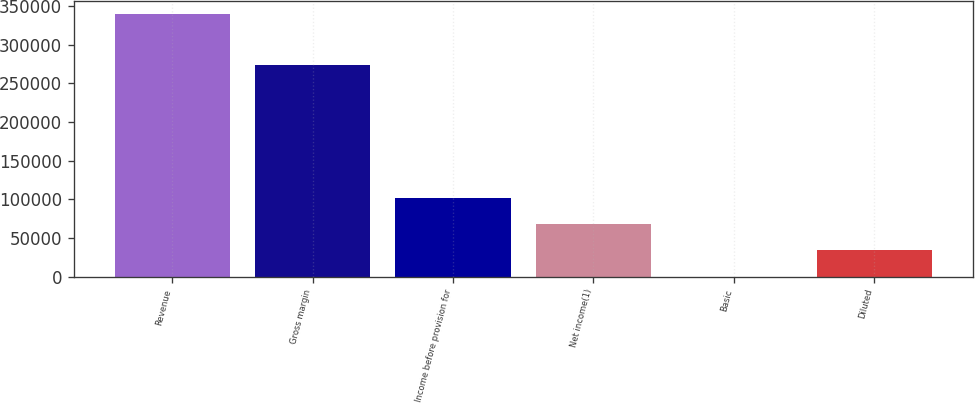<chart> <loc_0><loc_0><loc_500><loc_500><bar_chart><fcel>Revenue<fcel>Gross margin<fcel>Income before provision for<fcel>Net income(1)<fcel>Basic<fcel>Diluted<nl><fcel>339755<fcel>274331<fcel>101927<fcel>67951.3<fcel>0.37<fcel>33975.8<nl></chart> 